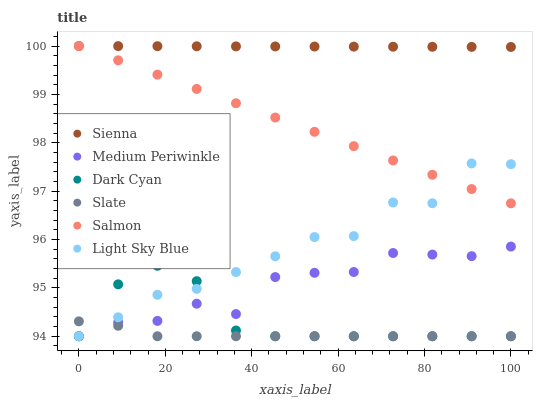Does Slate have the minimum area under the curve?
Answer yes or no. Yes. Does Sienna have the maximum area under the curve?
Answer yes or no. Yes. Does Medium Periwinkle have the minimum area under the curve?
Answer yes or no. No. Does Medium Periwinkle have the maximum area under the curve?
Answer yes or no. No. Is Salmon the smoothest?
Answer yes or no. Yes. Is Light Sky Blue the roughest?
Answer yes or no. Yes. Is Slate the smoothest?
Answer yes or no. No. Is Slate the roughest?
Answer yes or no. No. Does Slate have the lowest value?
Answer yes or no. Yes. Does Sienna have the lowest value?
Answer yes or no. No. Does Sienna have the highest value?
Answer yes or no. Yes. Does Medium Periwinkle have the highest value?
Answer yes or no. No. Is Medium Periwinkle less than Salmon?
Answer yes or no. Yes. Is Salmon greater than Slate?
Answer yes or no. Yes. Does Light Sky Blue intersect Dark Cyan?
Answer yes or no. Yes. Is Light Sky Blue less than Dark Cyan?
Answer yes or no. No. Is Light Sky Blue greater than Dark Cyan?
Answer yes or no. No. Does Medium Periwinkle intersect Salmon?
Answer yes or no. No. 